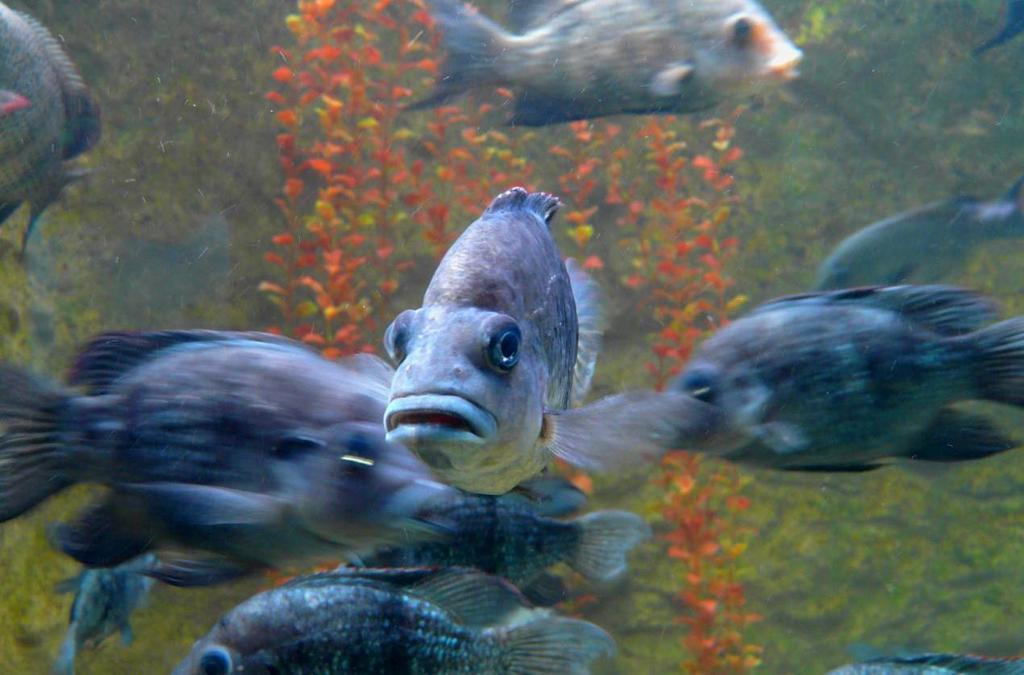What type of animals can be seen in the image? There is a shoal of fish in the image. What other elements are present in the image besides the fish? There are submarine plants in the image. Where might this image have been taken? The image may have been taken in the sea, given the presence of fish and submarine plants. What type of stew is being prepared by the friend in the image? There is no friend or stew present in the image; it features a shoal of fish and submarine plants. 